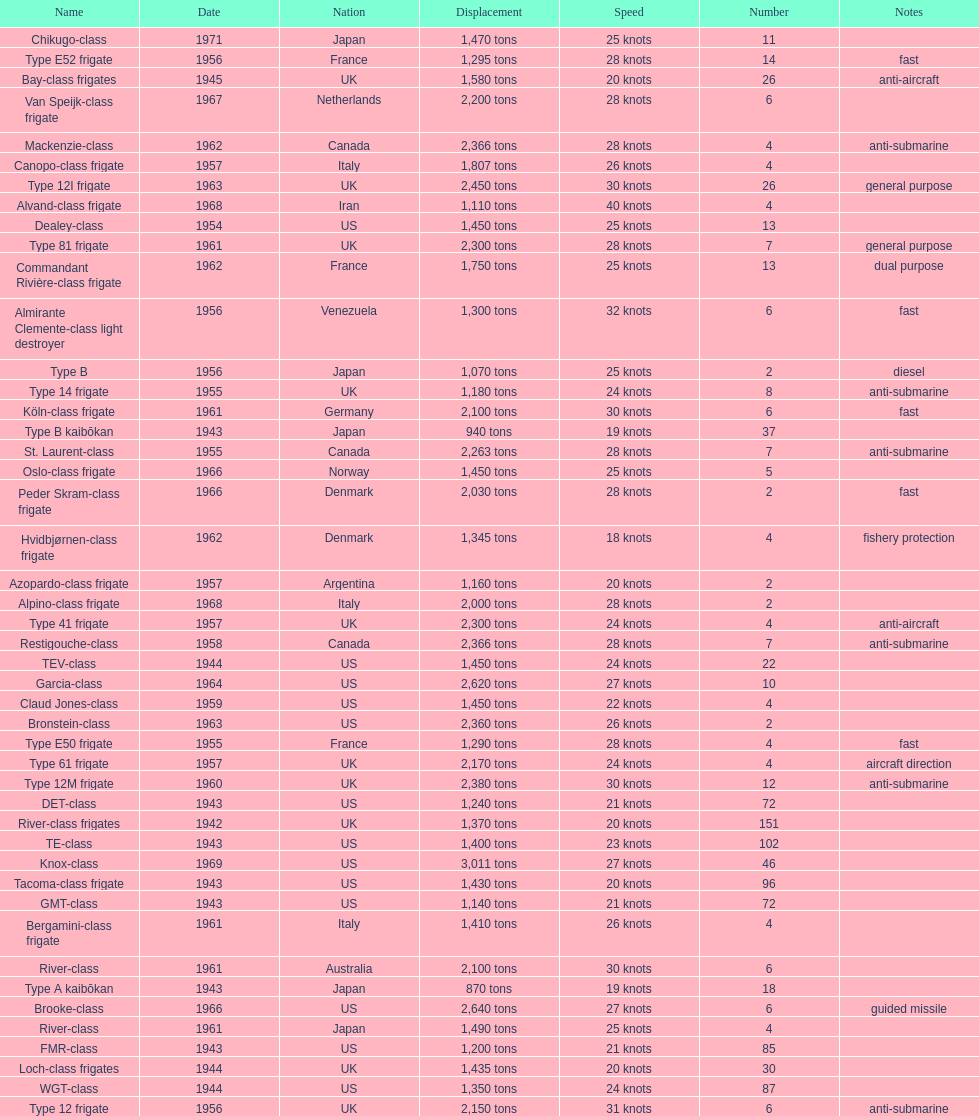Which name has the largest displacement? Knox-class. 